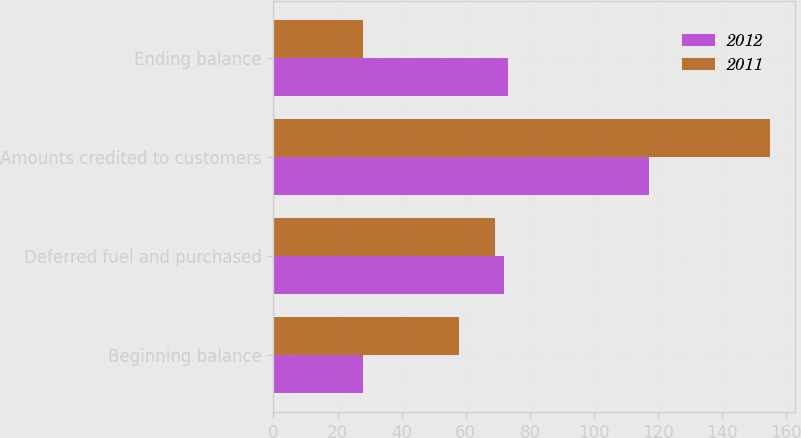Convert chart to OTSL. <chart><loc_0><loc_0><loc_500><loc_500><stacked_bar_chart><ecel><fcel>Beginning balance<fcel>Deferred fuel and purchased<fcel>Amounts credited to customers<fcel>Ending balance<nl><fcel>2012<fcel>28<fcel>72<fcel>117<fcel>73<nl><fcel>2011<fcel>58<fcel>69<fcel>155<fcel>28<nl></chart> 